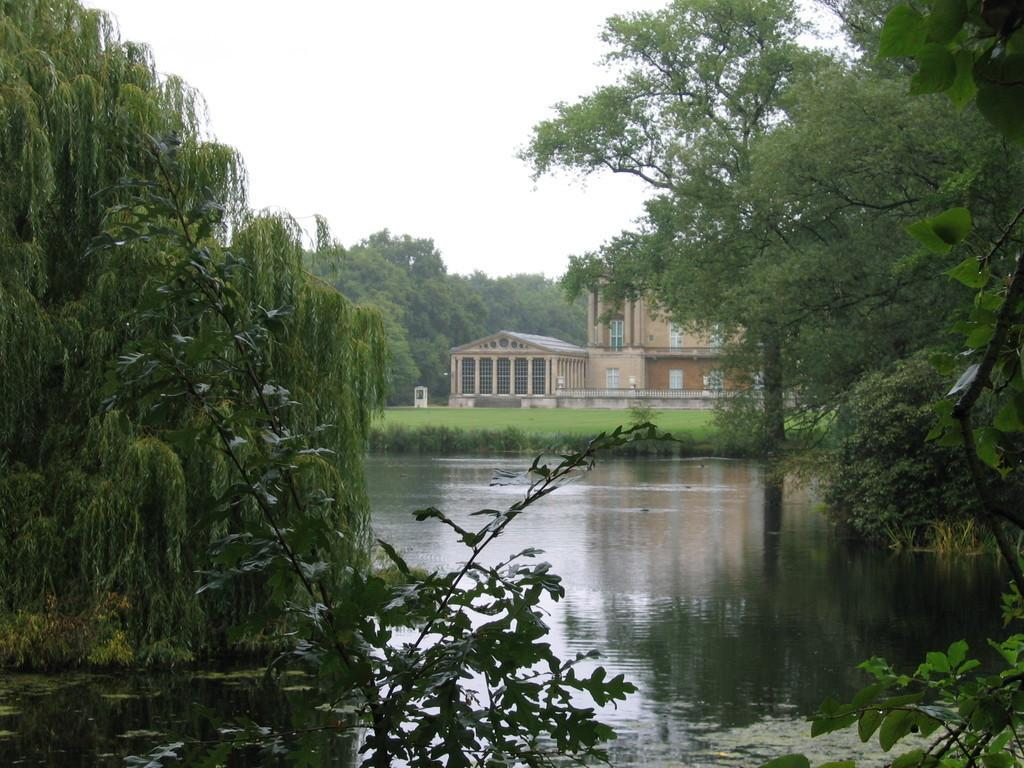What is the primary element visible in the image? There is water in the image. What type of vegetation can be seen in the image? There are trees in the image. What type of structure is present in the image? There is a building in the image. What is the ground covered with in the image? There is grass on the ground in the image. What is the condition of the sky in the image? The sky is cloudy in the image. How many feet are visible in the image? There are no feet present in the image. What type of agricultural equipment can be seen in the image? There is no plough or any agricultural equipment present in the image. 